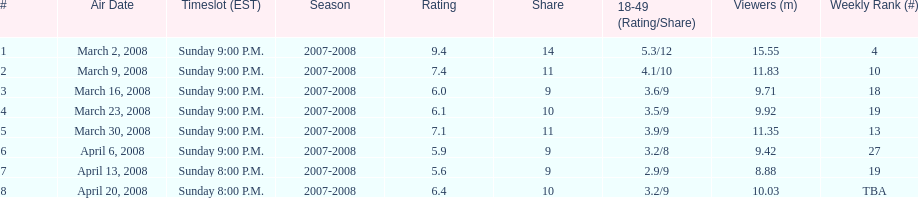The air date with the most viewers March 2, 2008. 